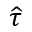<formula> <loc_0><loc_0><loc_500><loc_500>\widehat { \tau }</formula> 